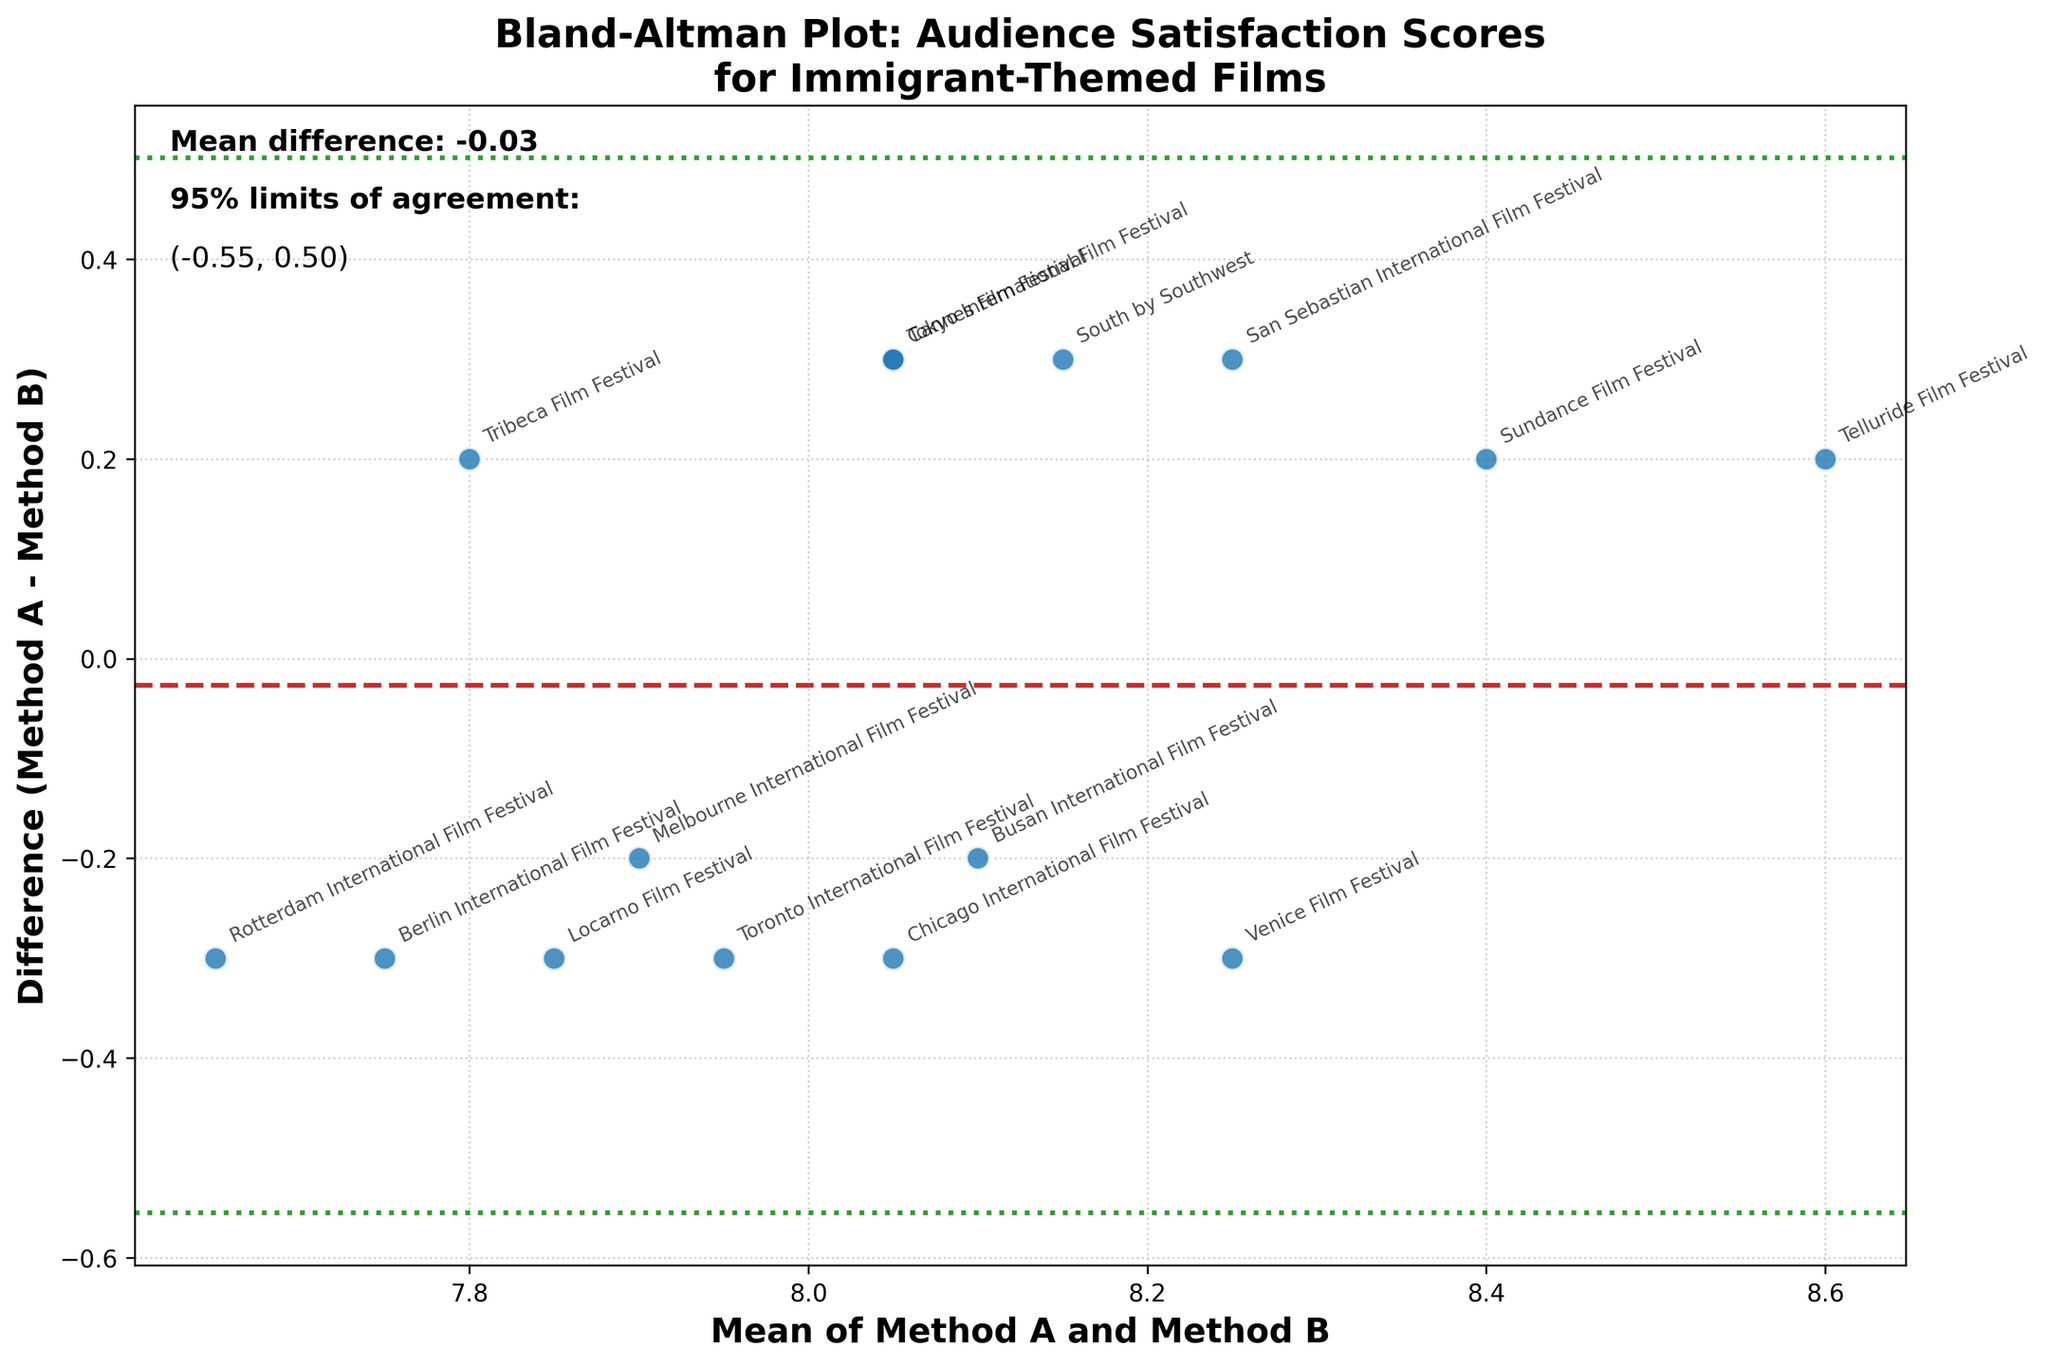What's the title of the figure? The title is typically found at the top of the plot, often in a larger and bold font for emphasis. In this figure, it states "Bland-Altman Plot: Audience Satisfaction Scores for Immigrant-Themed Films."
Answer: Bland-Altman Plot: Audience Satisfaction Scores for Immigrant-Themed Films How many data points are represented in the plot? The total number of data points can be found by counting the distinct points (usually circles) scattered across the plot. In this case, each point represents a film festival.
Answer: 15 What do the x-axis and y-axis represent? The axis labels provide this information. On the x-axis, it is labeled as "Mean of Method A and Method B," indicating it shows the average score of the two methods. The y-axis is labeled "Difference (Method A - Method B)," showing the score difference between the two methods.
Answer: x-axis: Mean of Method A and Method B, y-axis: Difference (Method A - Method B) What is the mean difference between Method A and Method B scores, and how is it indicated in the plot? The mean difference is typically a horizontal line in a different color, often annotated directly. Here, it's shown as a red dashed line and text annotation, stating the mean difference as approximately 0.00.
Answer: The mean difference is indicated by a red dashed line at 0.00 Which film festival has the largest mean score between Method A and Method B, and what is its value? The largest mean score is the rightmost point on the x-axis. In this case, it is the point annotated with "Telluride Film Festival," with a mean score of about 8.6.
Answer: Telluride Film Festival with a mean score of about 8.6 Are there any film festivals where the difference in scores between Method A and Method B is zero? If so, which one(s)? Zero difference points lie on the horizontal line where y=0. According to the figure, no points line up exactly on this line.
Answer: None What are the upper and lower 95% limits of agreement? These limits are typically shown as dotted lines in another color on the y-axis. The figure includes green dotted lines annotated with values approximately 0.37 and -0.37, representing the upper and lower limits, respectively.
Answer: Upper: 0.37, Lower: -0.37 Which film festival has the greatest discrepancy between Method A and Method B, and what is the value of this discrepancy? The biggest discrepancy is the point farthest from the y=0 line. In this plot, it appears to be the "Sundance Film Festival," with a difference close to 0.2.
Answer: Sundance Film Festival with a difference around 0.2 